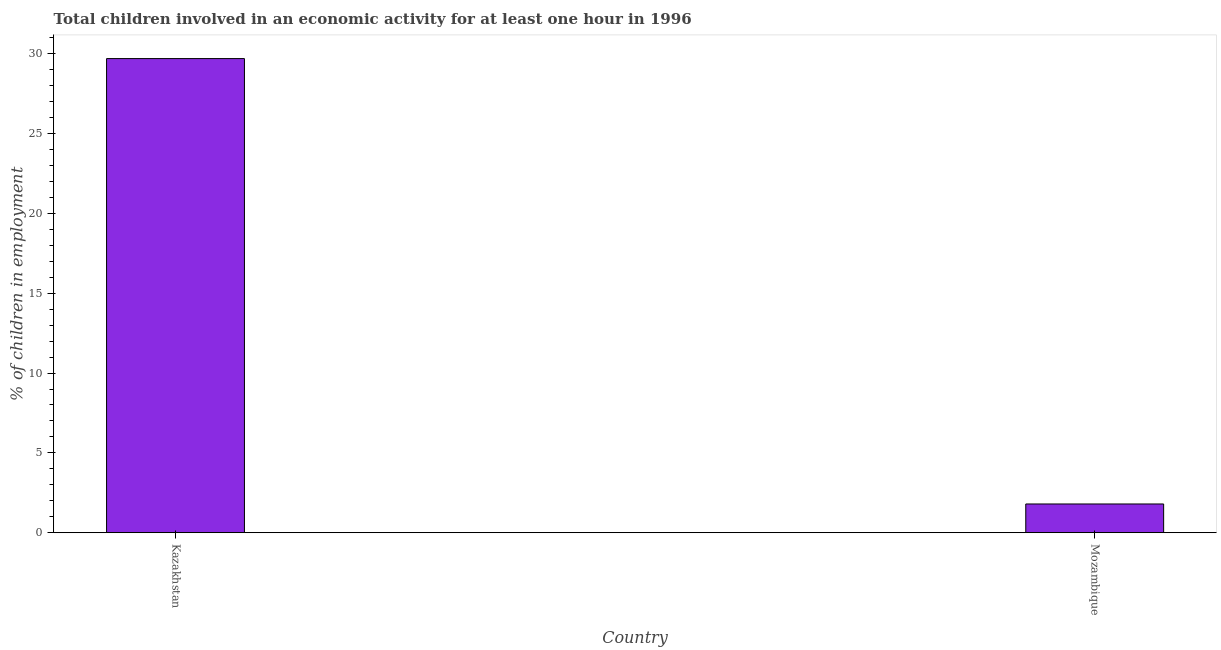Does the graph contain any zero values?
Your response must be concise. No. Does the graph contain grids?
Provide a succinct answer. No. What is the title of the graph?
Provide a succinct answer. Total children involved in an economic activity for at least one hour in 1996. What is the label or title of the X-axis?
Keep it short and to the point. Country. What is the label or title of the Y-axis?
Offer a very short reply. % of children in employment. What is the percentage of children in employment in Mozambique?
Your answer should be very brief. 1.8. Across all countries, what is the maximum percentage of children in employment?
Give a very brief answer. 29.7. In which country was the percentage of children in employment maximum?
Offer a very short reply. Kazakhstan. In which country was the percentage of children in employment minimum?
Provide a short and direct response. Mozambique. What is the sum of the percentage of children in employment?
Provide a short and direct response. 31.5. What is the difference between the percentage of children in employment in Kazakhstan and Mozambique?
Your answer should be very brief. 27.9. What is the average percentage of children in employment per country?
Provide a succinct answer. 15.75. What is the median percentage of children in employment?
Your response must be concise. 15.75. In how many countries, is the percentage of children in employment greater than 23 %?
Give a very brief answer. 1. In how many countries, is the percentage of children in employment greater than the average percentage of children in employment taken over all countries?
Your response must be concise. 1. Are all the bars in the graph horizontal?
Offer a very short reply. No. How many countries are there in the graph?
Ensure brevity in your answer.  2. What is the difference between two consecutive major ticks on the Y-axis?
Your answer should be compact. 5. What is the % of children in employment of Kazakhstan?
Your answer should be very brief. 29.7. What is the difference between the % of children in employment in Kazakhstan and Mozambique?
Make the answer very short. 27.9. 